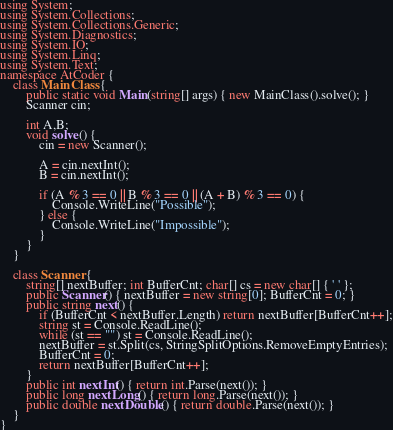<code> <loc_0><loc_0><loc_500><loc_500><_C#_>using System;
using System.Collections;
using System.Collections.Generic;
using System.Diagnostics;
using System.IO;
using System.Linq;
using System.Text;
namespace AtCoder {
    class MainClass {
        public static void Main(string[] args) { new MainClass().solve(); }
        Scanner cin;

        int A,B;
        void solve() {
            cin = new Scanner();

            A = cin.nextInt();
            B = cin.nextInt();

            if (A % 3 == 0 || B % 3 == 0 || (A + B) % 3 == 0) {
                Console.WriteLine("Possible");
            } else {
                Console.WriteLine("Impossible");
            }
        }
    }

    class Scanner {
        string[] nextBuffer; int BufferCnt; char[] cs = new char[] { ' ' };
        public Scanner() { nextBuffer = new string[0]; BufferCnt = 0; }
        public string next() {
            if (BufferCnt < nextBuffer.Length) return nextBuffer[BufferCnt++];
            string st = Console.ReadLine();
            while (st == "") st = Console.ReadLine();
            nextBuffer = st.Split(cs, StringSplitOptions.RemoveEmptyEntries);
            BufferCnt = 0;
            return nextBuffer[BufferCnt++];
        }
        public int nextInt() { return int.Parse(next()); }
        public long nextLong() { return long.Parse(next()); }
        public double nextDouble() { return double.Parse(next()); }
    }
}</code> 